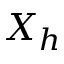Convert formula to latex. <formula><loc_0><loc_0><loc_500><loc_500>X _ { h }</formula> 